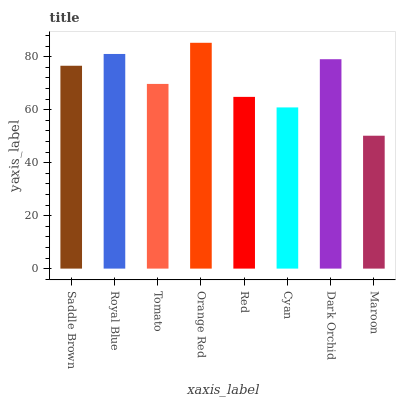Is Maroon the minimum?
Answer yes or no. Yes. Is Orange Red the maximum?
Answer yes or no. Yes. Is Royal Blue the minimum?
Answer yes or no. No. Is Royal Blue the maximum?
Answer yes or no. No. Is Royal Blue greater than Saddle Brown?
Answer yes or no. Yes. Is Saddle Brown less than Royal Blue?
Answer yes or no. Yes. Is Saddle Brown greater than Royal Blue?
Answer yes or no. No. Is Royal Blue less than Saddle Brown?
Answer yes or no. No. Is Saddle Brown the high median?
Answer yes or no. Yes. Is Tomato the low median?
Answer yes or no. Yes. Is Cyan the high median?
Answer yes or no. No. Is Saddle Brown the low median?
Answer yes or no. No. 